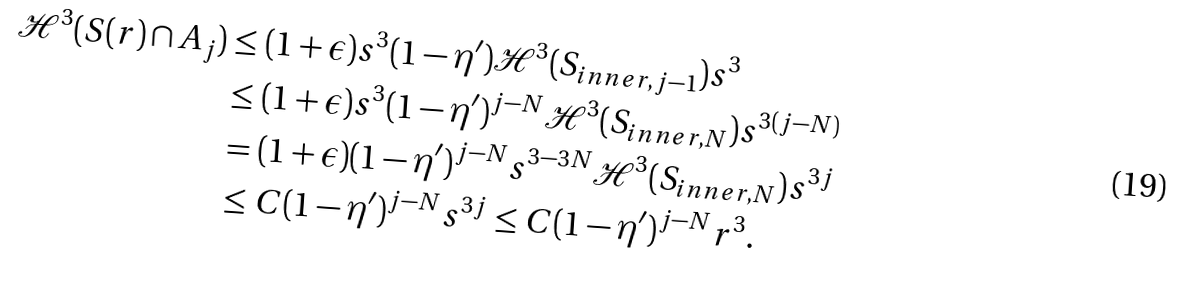Convert formula to latex. <formula><loc_0><loc_0><loc_500><loc_500>\mathcal { H } ^ { 3 } ( S ( r ) \cap A _ { j } ) & \leq ( 1 + \epsilon ) s ^ { 3 } ( 1 - \eta ^ { \prime } ) \mathcal { H } ^ { 3 } ( S _ { i n n e r , j - 1 } ) s ^ { 3 } \\ & \leq ( 1 + \epsilon ) s ^ { 3 } ( 1 - \eta ^ { \prime } ) ^ { j - N } \mathcal { H } ^ { 3 } ( S _ { i n n e r , N } ) s ^ { 3 ( j - N ) } \\ & = ( 1 + \epsilon ) ( 1 - \eta ^ { \prime } ) ^ { j - N } s ^ { 3 - 3 N } \mathcal { H } ^ { 3 } ( S _ { i n n e r , N } ) s ^ { 3 j } \\ & \leq C ( 1 - \eta ^ { \prime } ) ^ { j - N } s ^ { 3 j } \leq C ( 1 - \eta ^ { \prime } ) ^ { j - N } r ^ { 3 } .</formula> 